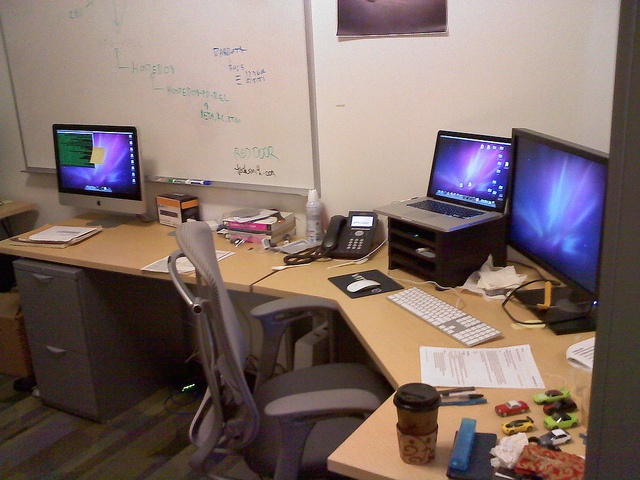Describe the objects in this image and their specific colors. I can see chair in gray and black tones, tv in gray, blue, black, navy, and darkblue tones, laptop in gray, black, violet, navy, and darkgray tones, tv in gray, black, blue, and magenta tones, and cup in gray, maroon, black, and tan tones in this image. 